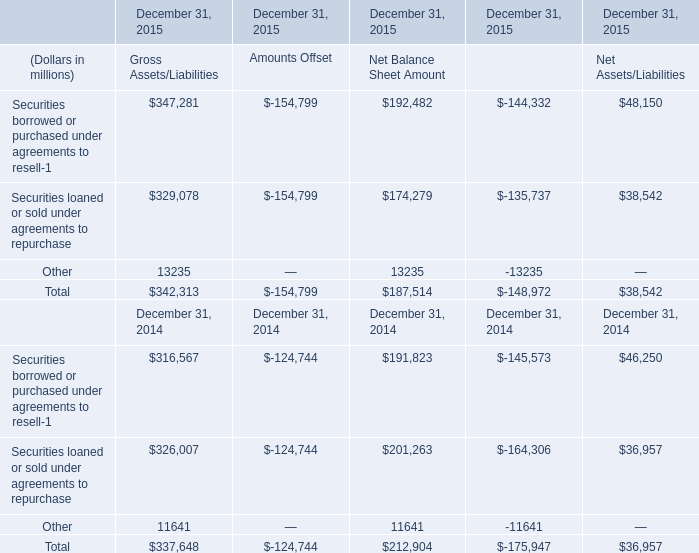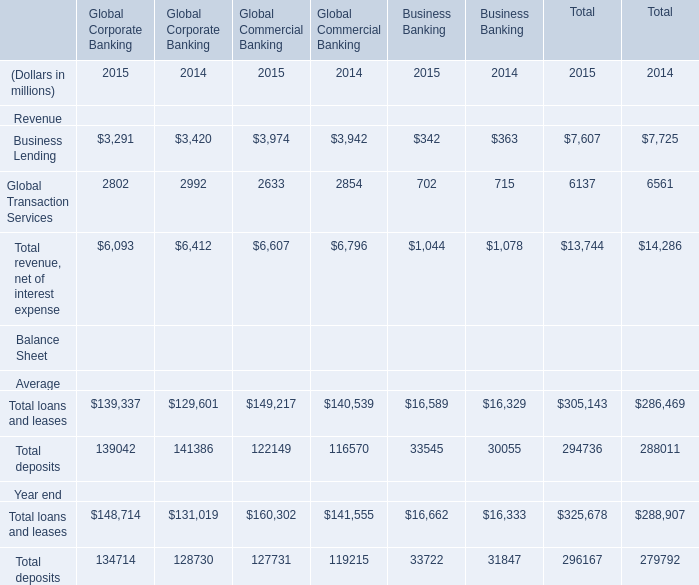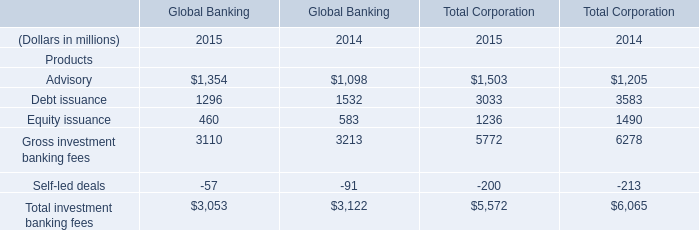What is the average amount of Business Lending of Global Commercial Banking 2014, and Debt issuance of Global Banking 2015 ? 
Computations: ((3942.0 + 1296.0) / 2)
Answer: 2619.0. 